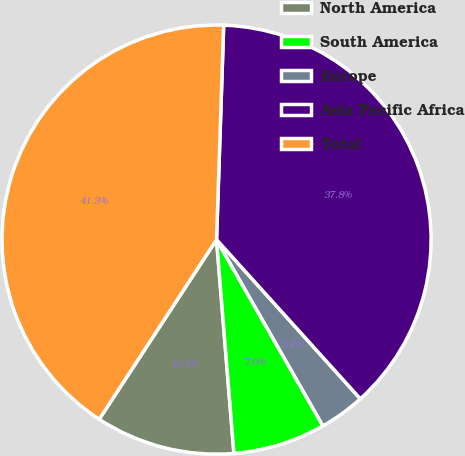<chart> <loc_0><loc_0><loc_500><loc_500><pie_chart><fcel>North America<fcel>South America<fcel>Europe<fcel>Asia Pacific Africa<fcel>Total<nl><fcel>10.5%<fcel>6.97%<fcel>3.43%<fcel>37.78%<fcel>41.32%<nl></chart> 